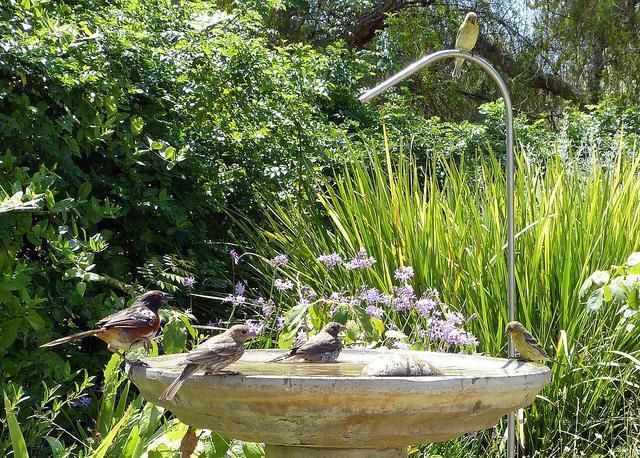How many birds are there?
Give a very brief answer. 5. 